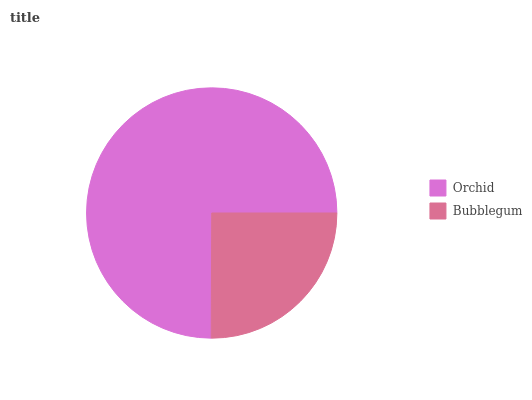Is Bubblegum the minimum?
Answer yes or no. Yes. Is Orchid the maximum?
Answer yes or no. Yes. Is Bubblegum the maximum?
Answer yes or no. No. Is Orchid greater than Bubblegum?
Answer yes or no. Yes. Is Bubblegum less than Orchid?
Answer yes or no. Yes. Is Bubblegum greater than Orchid?
Answer yes or no. No. Is Orchid less than Bubblegum?
Answer yes or no. No. Is Orchid the high median?
Answer yes or no. Yes. Is Bubblegum the low median?
Answer yes or no. Yes. Is Bubblegum the high median?
Answer yes or no. No. Is Orchid the low median?
Answer yes or no. No. 